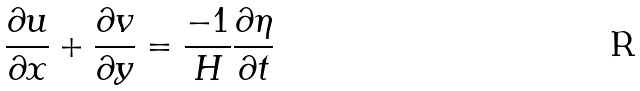<formula> <loc_0><loc_0><loc_500><loc_500>\frac { \partial u } { \partial x } + \frac { \partial v } { \partial y } = \frac { - 1 } { H } \frac { \partial \eta } { \partial t }</formula> 